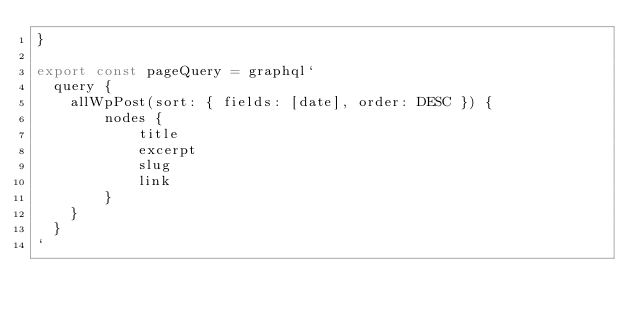Convert code to text. <code><loc_0><loc_0><loc_500><loc_500><_JavaScript_>}

export const pageQuery = graphql`
  query {
    allWpPost(sort: { fields: [date], order: DESC }) {
        nodes {
            title
            excerpt
            slug
            link
        }
    }
  }
`</code> 